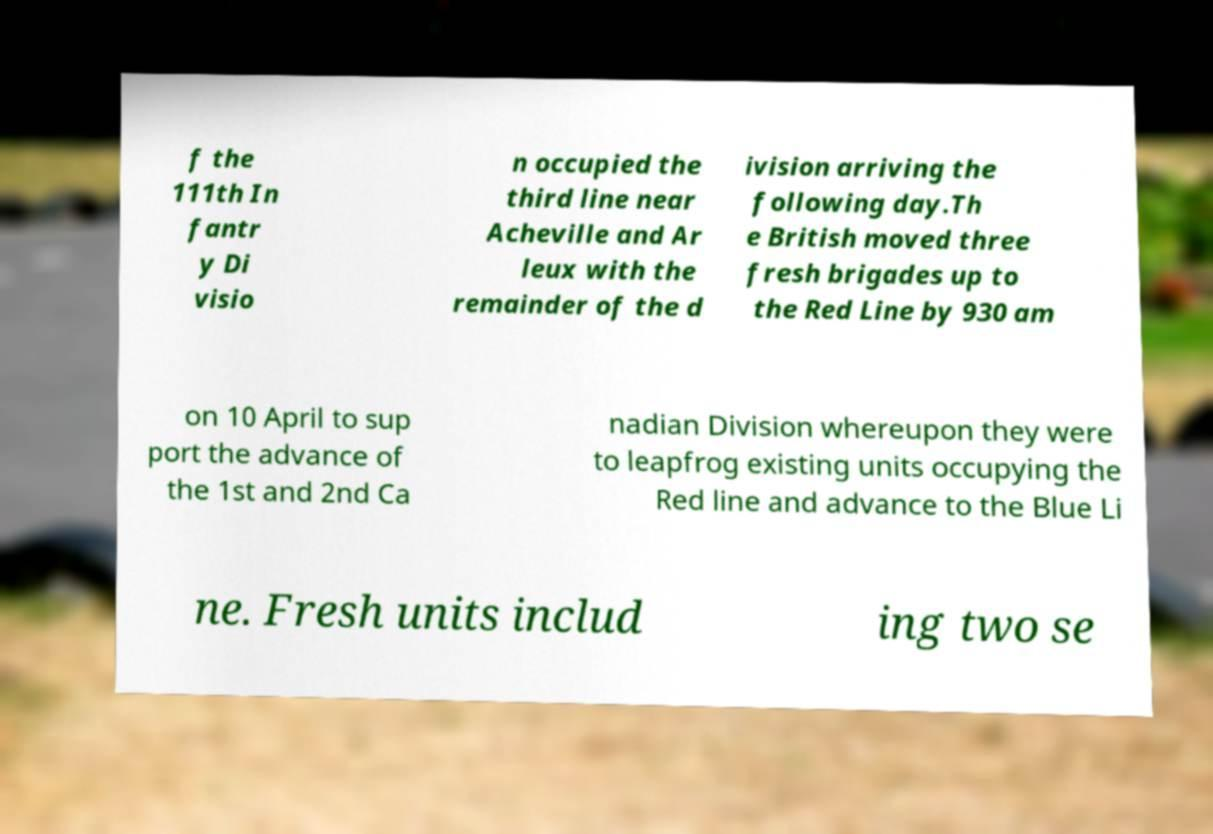I need the written content from this picture converted into text. Can you do that? f the 111th In fantr y Di visio n occupied the third line near Acheville and Ar leux with the remainder of the d ivision arriving the following day.Th e British moved three fresh brigades up to the Red Line by 930 am on 10 April to sup port the advance of the 1st and 2nd Ca nadian Division whereupon they were to leapfrog existing units occupying the Red line and advance to the Blue Li ne. Fresh units includ ing two se 